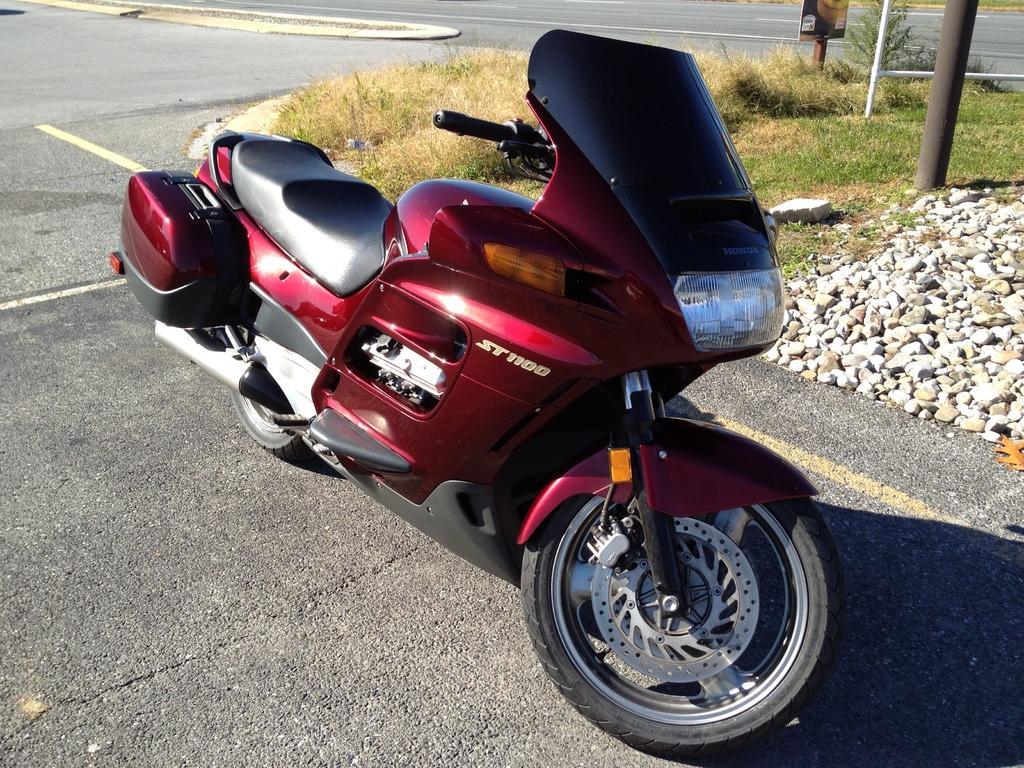Please provide a concise description of this image. In center of the image there is a bike on the road. To the right side of the image there are stones. There is grass. There are poles. 